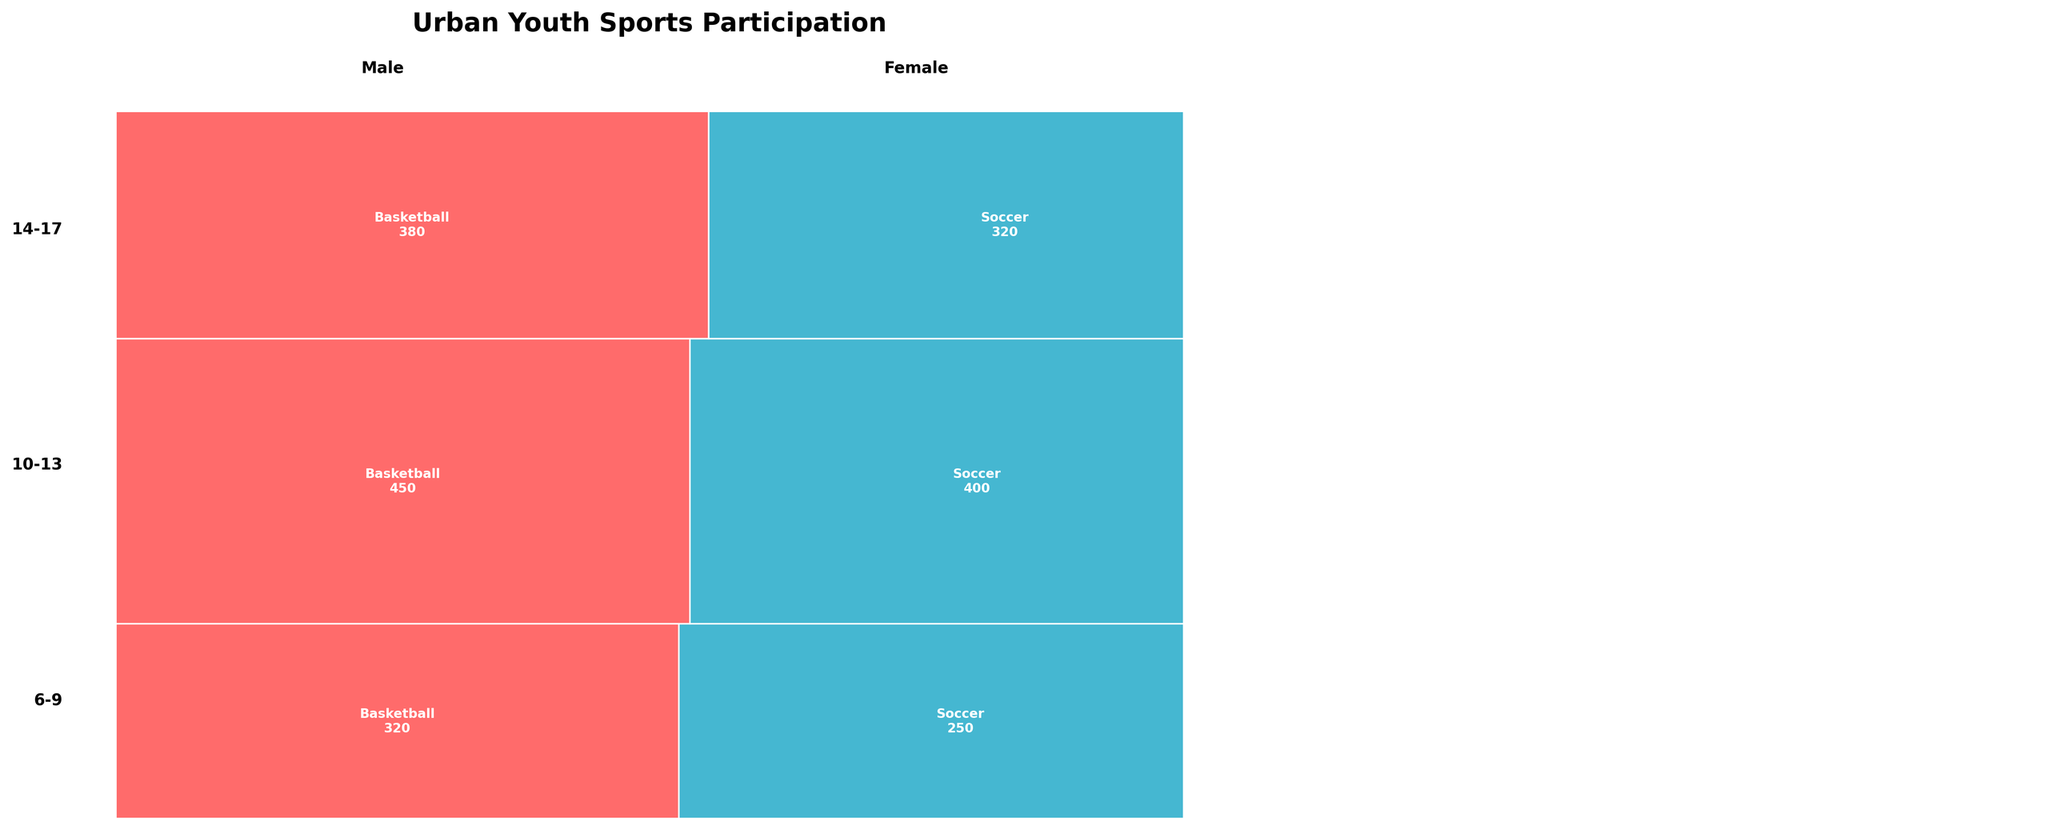How many age groups are represented in the plot? The plot categorizes participation rates across different age groups. By counting the distinct sections on the Y-axis representing age groups, we can determine the number.
Answer: 3 What is the participation rate for 10-13-year-old females in soccer? Locate the section of the plot corresponding to 10-13-year-old females, then find the text that specifies the participation rate for soccer within that section.
Answer: 350 Which program has higher overall participation rates for 6-9-year-olds: Basketball or Soccer? Compare the sum of the participation rates for Basketball and Soccer within the 6-9-year-old group by adding up the figures given for both genders. Basketball has 320+280=600, and Soccer has 250+230=480, hence Basketball is higher.
Answer: Basketball What is the total participation rate for the 14-17 age group? Add up the participation rates for both genders in both programs within the 14-17 age group. For males and females: 380 + 290 + 320 + 270. The total is 1260.
Answer: 1260 Which gender has higher participation in basketball for 10-13-year-olds, and by how much? Compare the participation rates between males and females in basketball for the 10-13 age group. Males have 450, and females have 380. The difference is 450 - 380 = 70.
Answer: Male, by 70 What is the difference in participation rates between males and females in the 6-9 age group for soccer? Identify the participation rates for males and females in soccer for the 6-9 age group: Males 250 and Females 230. The difference is 250 - 230 = 20.
Answer: 20 How does the participation rate for 14-17-year-old females in Basketball compare to 10-13-year-old females in Soccer? Compare the participation rates for 14-17-year-old females in Basketball (290) and 10-13-year-old females in Soccer (350).
Answer: 60 less What portion of the total participation rate is made up by the 10-13-year-old males playing soccer? Calculate the proportion using the participation rate for 10-13-year-old males in soccer (400) over the total participation rate. First, calculate total participation: 3,860. Therefore, the portion is 400 / 3,860 = 0.1036 (10.36%).
Answer: 10.36% 